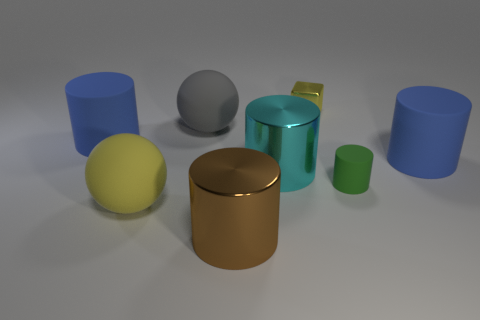Subtract all brown shiny cylinders. How many cylinders are left? 4 Subtract all brown blocks. How many blue cylinders are left? 2 Add 1 gray balls. How many objects exist? 9 Subtract 3 cylinders. How many cylinders are left? 2 Subtract all green cylinders. How many cylinders are left? 4 Subtract all blue cylinders. Subtract all purple blocks. How many cylinders are left? 3 Subtract all blocks. How many objects are left? 7 Add 8 cyan things. How many cyan things are left? 9 Add 5 blue cylinders. How many blue cylinders exist? 7 Subtract 0 brown spheres. How many objects are left? 8 